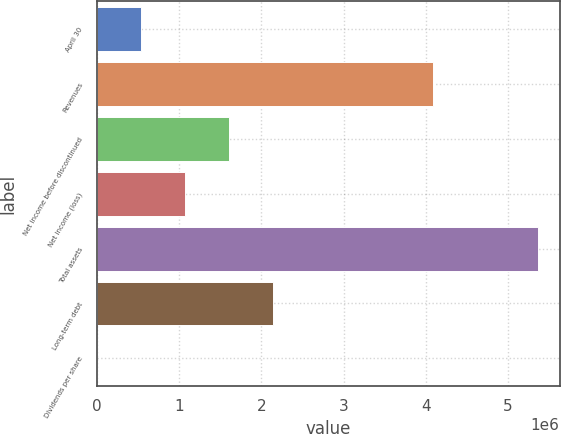Convert chart. <chart><loc_0><loc_0><loc_500><loc_500><bar_chart><fcel>April 30<fcel>Revenues<fcel>Net income before discontinued<fcel>Net income (loss)<fcel>Total assets<fcel>Long-term debt<fcel>Dividends per share<nl><fcel>535973<fcel>4.08358e+06<fcel>1.60792e+06<fcel>1.07194e+06<fcel>5.35972e+06<fcel>2.14389e+06<fcel>0.59<nl></chart> 